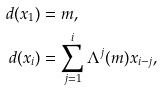Convert formula to latex. <formula><loc_0><loc_0><loc_500><loc_500>d ( x _ { 1 } ) & = m , \\ d ( x _ { i } ) & = \sum _ { j = 1 } ^ { i } \Lambda ^ { j } ( m ) x _ { i - j } ,</formula> 